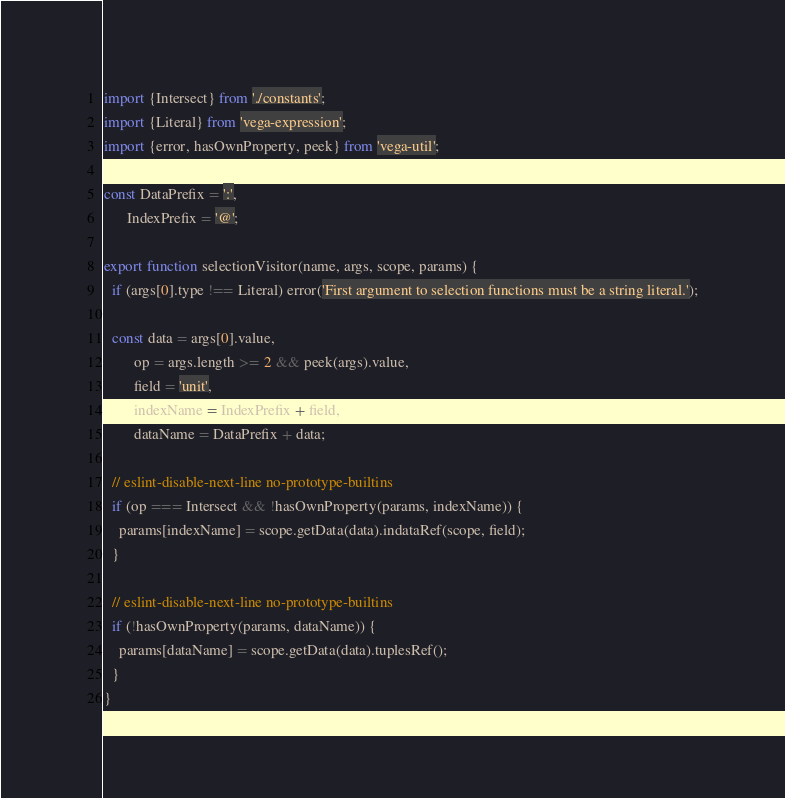Convert code to text. <code><loc_0><loc_0><loc_500><loc_500><_JavaScript_>import {Intersect} from './constants';
import {Literal} from 'vega-expression';
import {error, hasOwnProperty, peek} from 'vega-util';

const DataPrefix = ':',
      IndexPrefix = '@';

export function selectionVisitor(name, args, scope, params) {
  if (args[0].type !== Literal) error('First argument to selection functions must be a string literal.');

  const data = args[0].value,
        op = args.length >= 2 && peek(args).value,
        field = 'unit',
        indexName = IndexPrefix + field,
        dataName = DataPrefix + data;

  // eslint-disable-next-line no-prototype-builtins
  if (op === Intersect && !hasOwnProperty(params, indexName)) {
    params[indexName] = scope.getData(data).indataRef(scope, field);
  }

  // eslint-disable-next-line no-prototype-builtins
  if (!hasOwnProperty(params, dataName)) {
    params[dataName] = scope.getData(data).tuplesRef();
  }
}</code> 